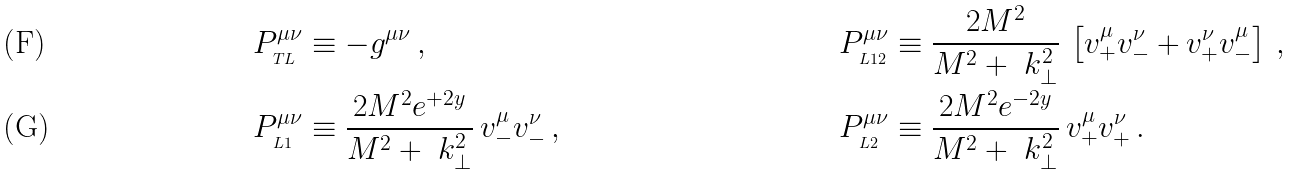<formula> <loc_0><loc_0><loc_500><loc_500>& P ^ { \mu \nu } _ { _ { T L } } \equiv - g ^ { \mu \nu } \, , \quad & & P ^ { \mu \nu } _ { _ { L 1 2 } } \equiv \frac { 2 M ^ { 2 } } { M ^ { 2 } + \ k _ { \perp } ^ { 2 } } \, \left [ v _ { + } ^ { \mu } v _ { - } ^ { \nu } + v _ { + } ^ { \nu } v _ { - } ^ { \mu } \right ] \, , \\ & P ^ { \mu \nu } _ { _ { L 1 } } \equiv \frac { 2 M ^ { 2 } e ^ { + 2 y } } { M ^ { 2 } + \ k _ { \perp } ^ { 2 } } \, v _ { - } ^ { \mu } v _ { - } ^ { \nu } \, , \quad & & P ^ { \mu \nu } _ { _ { L 2 } } \equiv \frac { 2 M ^ { 2 } e ^ { - 2 y } } { M ^ { 2 } + \ k _ { \perp } ^ { 2 } } \, v _ { + } ^ { \mu } v _ { + } ^ { \nu } \, .</formula> 